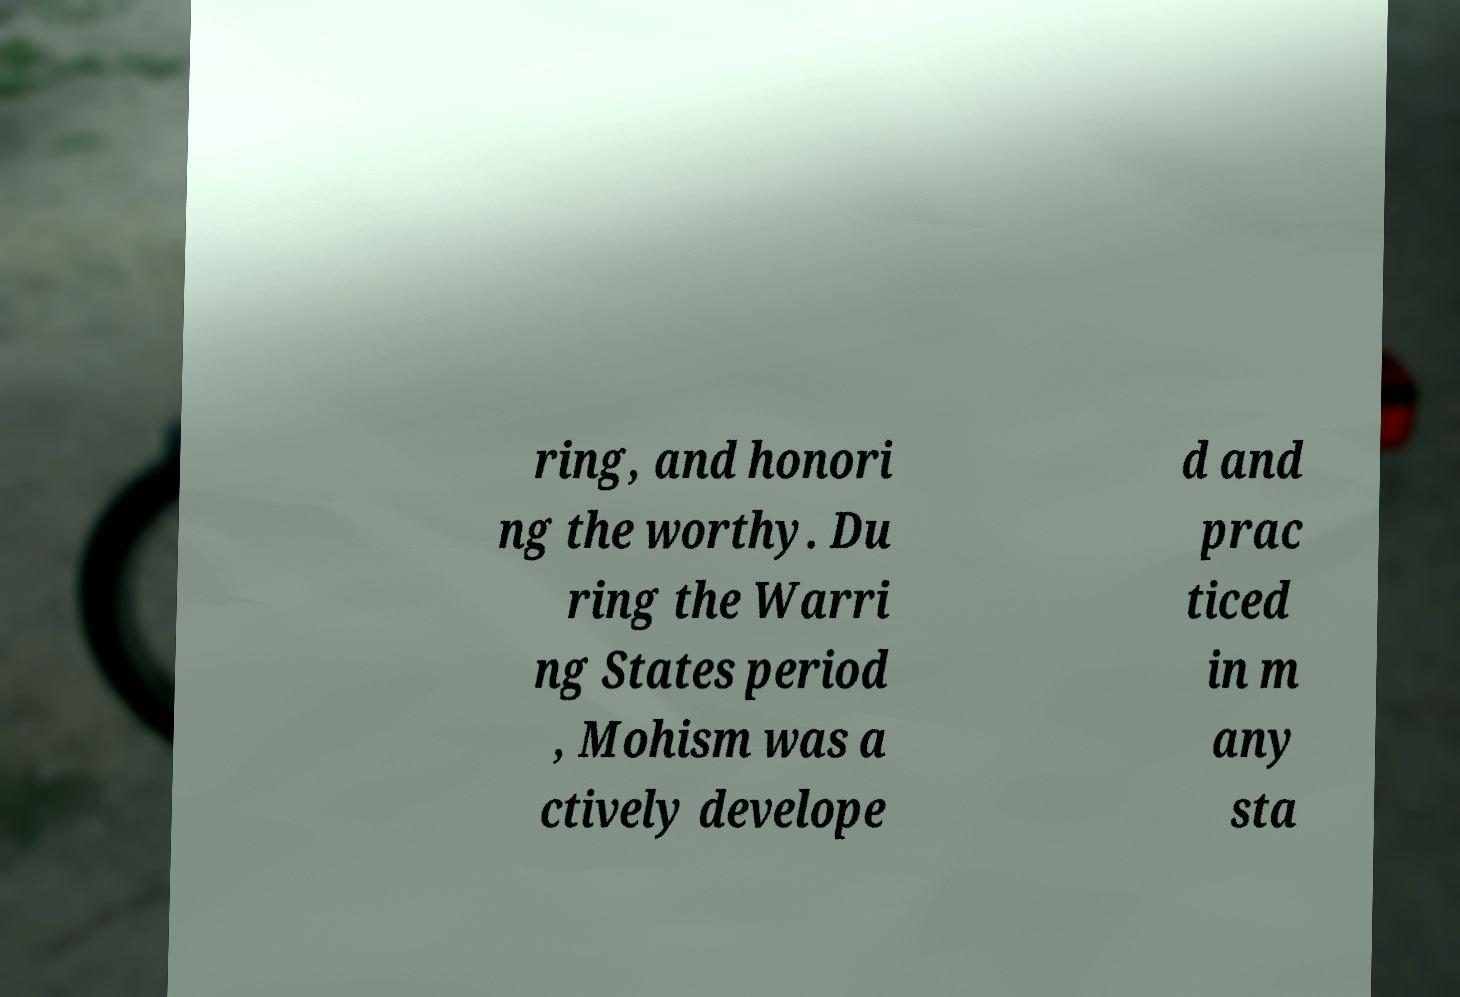Please identify and transcribe the text found in this image. ring, and honori ng the worthy. Du ring the Warri ng States period , Mohism was a ctively develope d and prac ticed in m any sta 